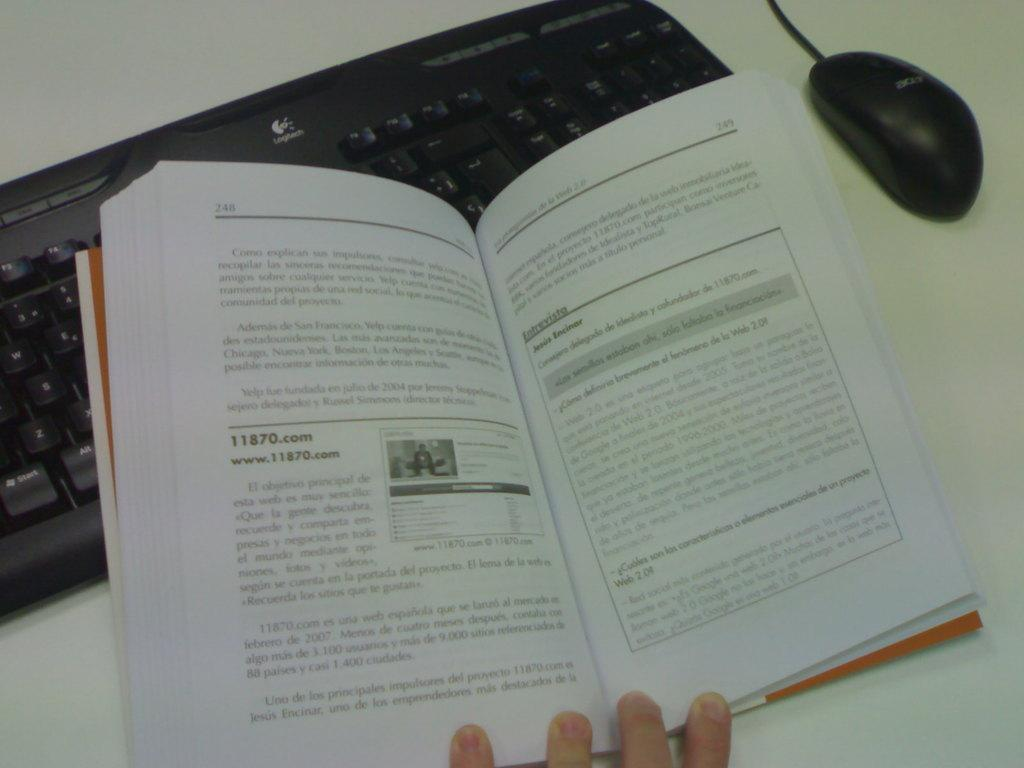<image>
Give a short and clear explanation of the subsequent image. A book is being held open to page 248. 